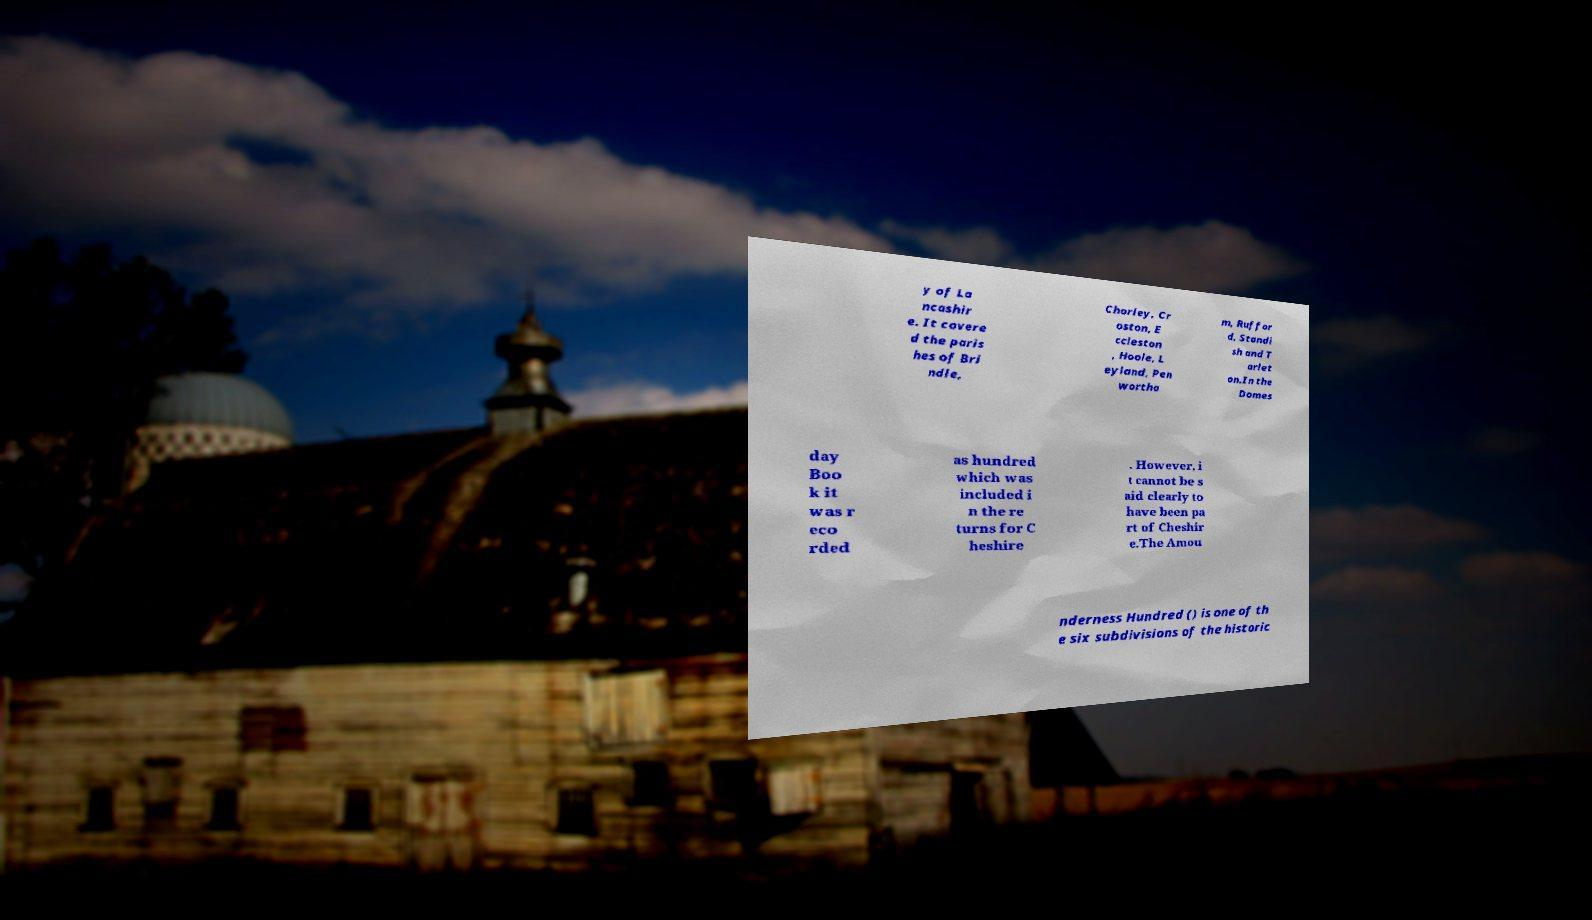Could you extract and type out the text from this image? y of La ncashir e. It covere d the paris hes of Bri ndle, Chorley, Cr oston, E ccleston , Hoole, L eyland, Pen wortha m, Ruffor d, Standi sh and T arlet on.In the Domes day Boo k it was r eco rded as hundred which was included i n the re turns for C heshire . However, i t cannot be s aid clearly to have been pa rt of Cheshir e.The Amou nderness Hundred () is one of th e six subdivisions of the historic 